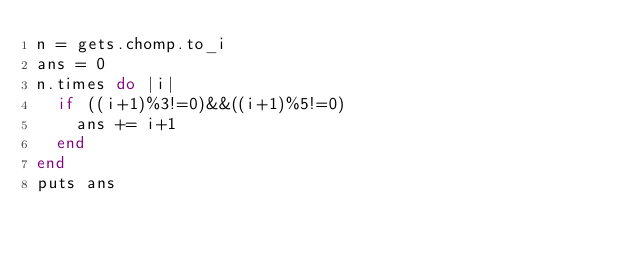Convert code to text. <code><loc_0><loc_0><loc_500><loc_500><_Ruby_>n = gets.chomp.to_i
ans = 0
n.times do |i|
  if ((i+1)%3!=0)&&((i+1)%5!=0)
    ans += i+1
  end
end
puts ans</code> 